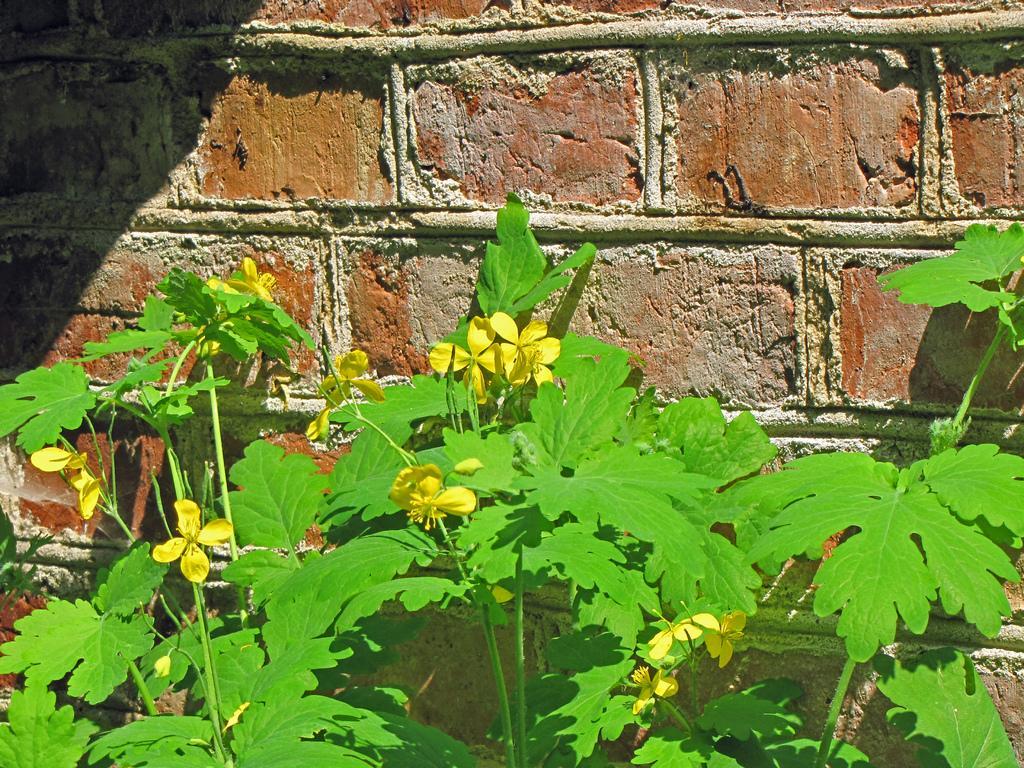Can you describe this image briefly? In this image there are some plants with some flowers in the bottom of this image and there is a wall in the background. 